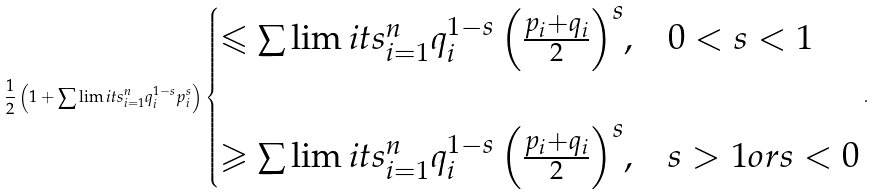Convert formula to latex. <formula><loc_0><loc_0><loc_500><loc_500>\frac { 1 } { 2 } \left ( { 1 + \sum \lim i t s _ { i = 1 } ^ { n } { q _ { i } ^ { 1 - s } p _ { i } ^ { s } } } \right ) \begin{cases} { \leqslant \sum \lim i t s _ { i = 1 } ^ { n } { q _ { i } ^ { 1 - s } \left ( { \frac { p _ { i } + q _ { i } } { 2 } } \right ) ^ { s } } , } & { 0 < s < 1 } \\ \\ { \geqslant \sum \lim i t s _ { i = 1 } ^ { n } { q _ { i } ^ { 1 - s } \left ( { \frac { p _ { i } + q _ { i } } { 2 } } \right ) ^ { s } } , } & { s > 1 o r s < 0 } \\ \end{cases} .</formula> 